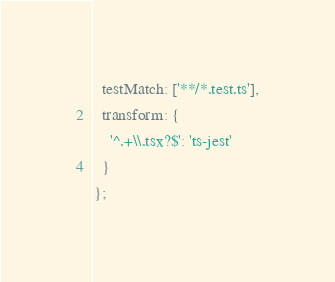Convert code to text. <code><loc_0><loc_0><loc_500><loc_500><_JavaScript_>  testMatch: ['**/*.test.ts'],
  transform: {
    '^.+\\.tsx?$': 'ts-jest'
  }
};
</code> 